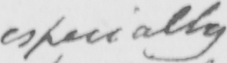What is written in this line of handwriting? especially 